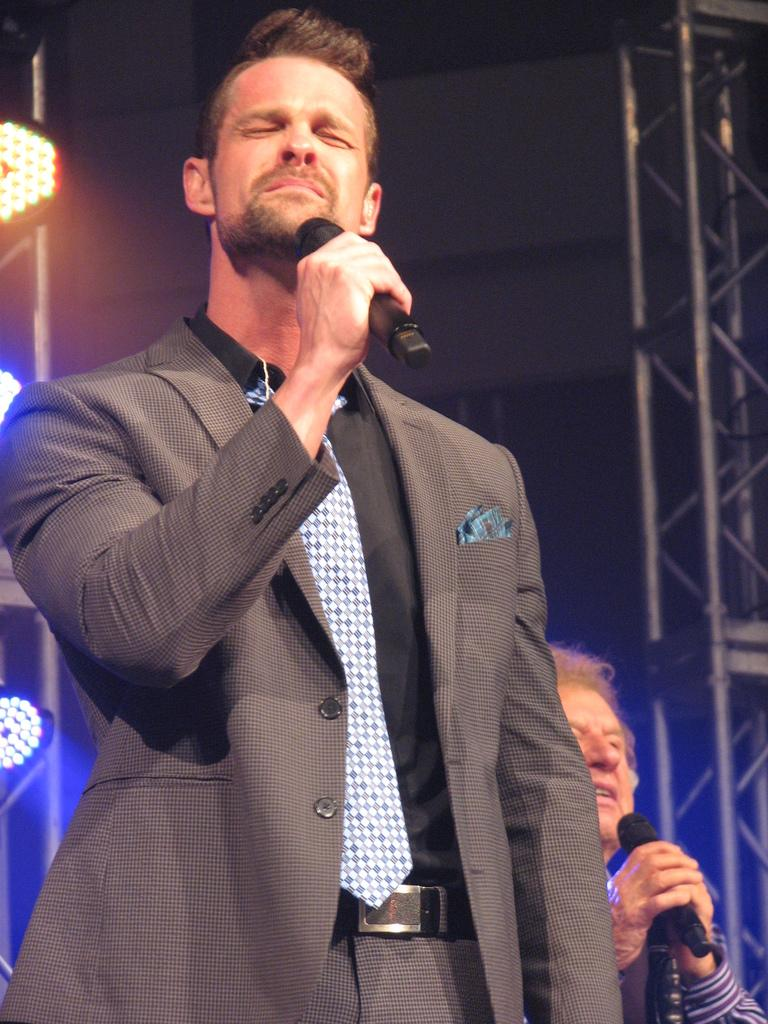What is the main subject of the image? The main subject of the image is a man. What is the man doing in the image? The man is standing in the image. What object is the man holding in the image? The man is holding a mic in the image. What time is displayed on the hydrant in the image? There is no hydrant present in the image, and therefore no time can be observed. 